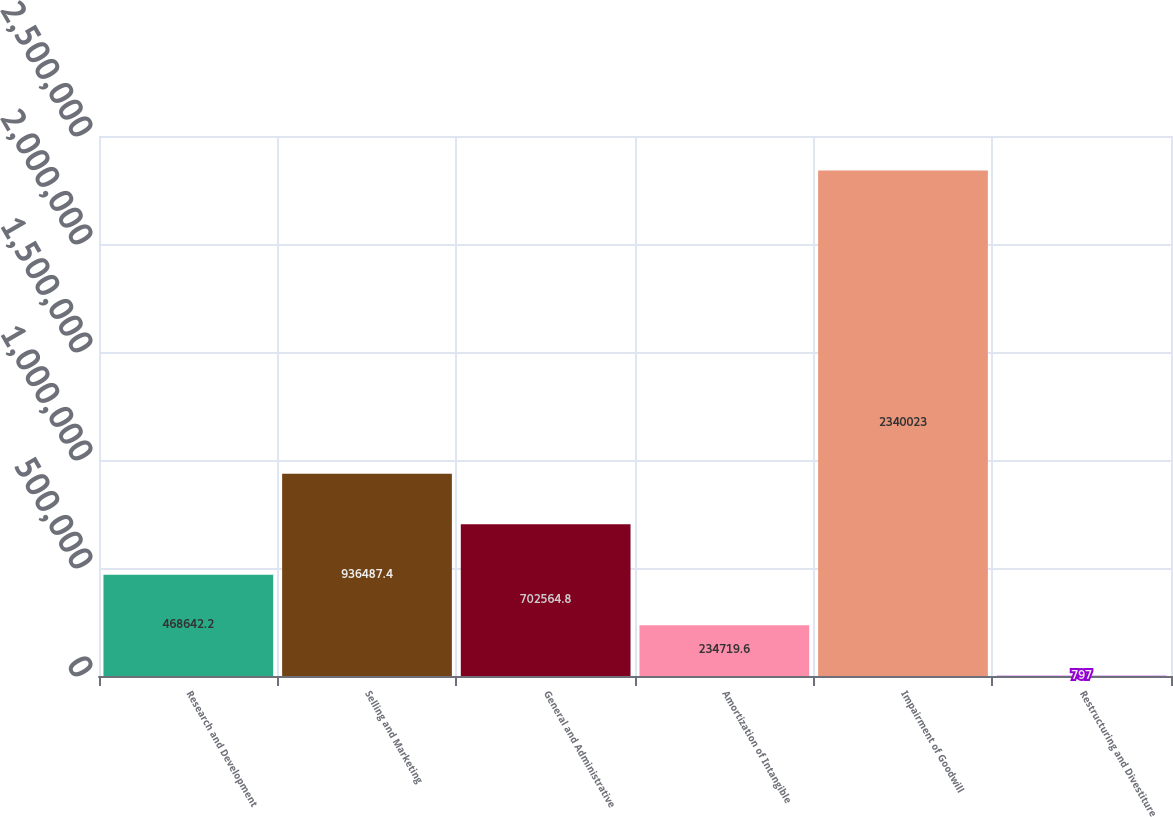Convert chart to OTSL. <chart><loc_0><loc_0><loc_500><loc_500><bar_chart><fcel>Research and Development<fcel>Selling and Marketing<fcel>General and Administrative<fcel>Amortization of Intangible<fcel>Impairment of Goodwill<fcel>Restructuring and Divestiture<nl><fcel>468642<fcel>936487<fcel>702565<fcel>234720<fcel>2.34002e+06<fcel>797<nl></chart> 